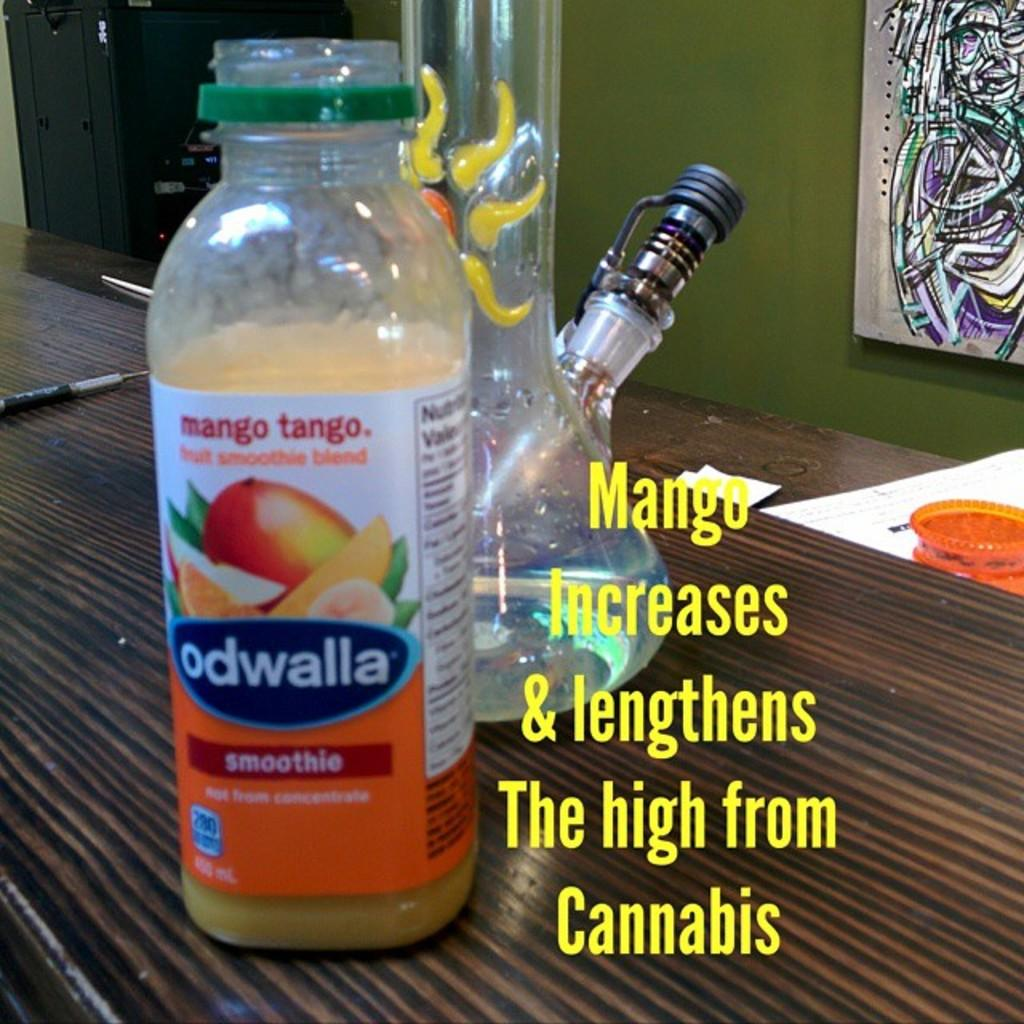What object is placed on the table in the image? There is a bottle on a table in the image. What can be seen attached to a wall in the background of the image? There is a frame attached to a wall in the background of the image. What song is playing in the background of the image? There is no information about a song playing in the background of the image. Is there any indication of tax-related activities in the image? There is no information about tax-related activities in the image. 